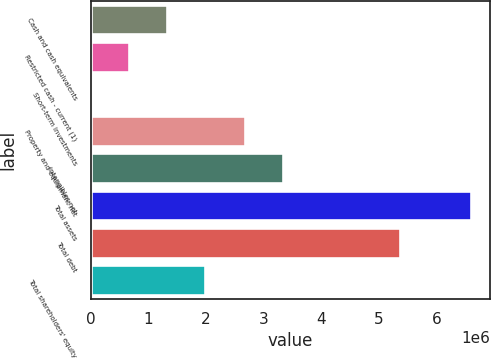Convert chart to OTSL. <chart><loc_0><loc_0><loc_500><loc_500><bar_chart><fcel>Cash and cash equivalents<fcel>Restricted cash - current (1)<fcel>Short-term investments<fcel>Property and equipment net<fcel>Intangibles net<fcel>Total assets<fcel>Total debt<fcel>Total shareholders' equity<nl><fcel>1.3235e+06<fcel>664486<fcel>5471<fcel>2.67132e+06<fcel>3.33033e+06<fcel>6.59562e+06<fcel>5.3561e+06<fcel>1.98251e+06<nl></chart> 